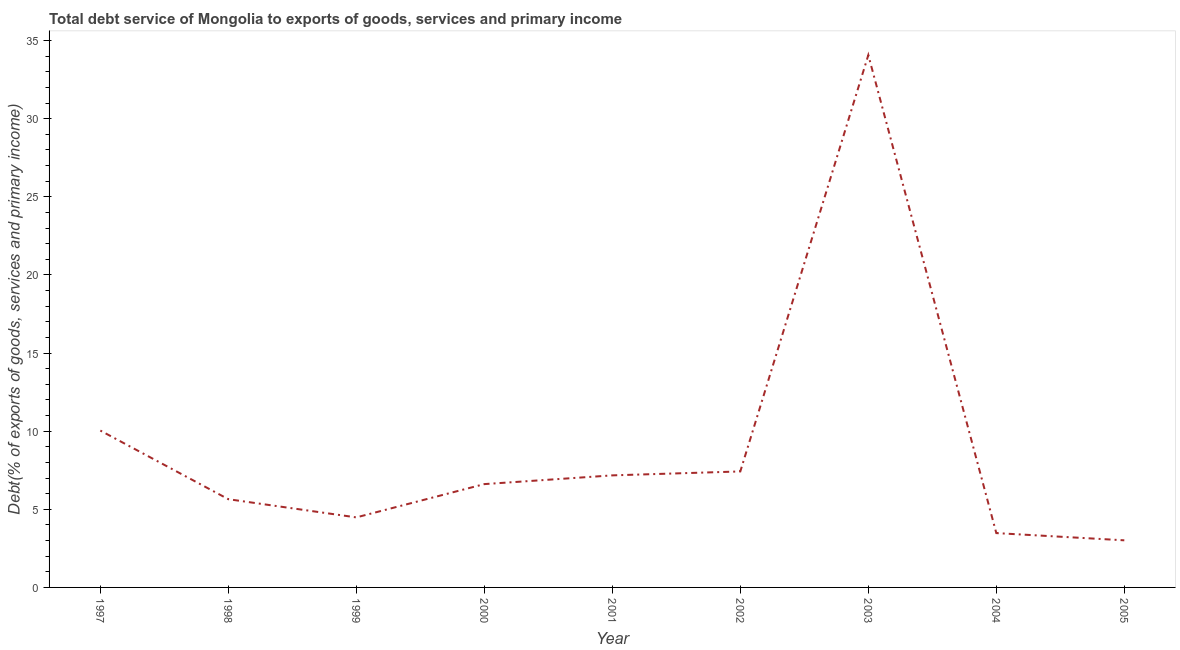What is the total debt service in 2005?
Provide a succinct answer. 3.02. Across all years, what is the maximum total debt service?
Provide a short and direct response. 34.07. Across all years, what is the minimum total debt service?
Provide a succinct answer. 3.02. In which year was the total debt service maximum?
Offer a very short reply. 2003. What is the sum of the total debt service?
Ensure brevity in your answer.  81.94. What is the difference between the total debt service in 1999 and 2004?
Make the answer very short. 1. What is the average total debt service per year?
Your response must be concise. 9.1. What is the median total debt service?
Offer a terse response. 6.61. In how many years, is the total debt service greater than 8 %?
Your answer should be very brief. 2. Do a majority of the years between 2001 and 2000 (inclusive) have total debt service greater than 34 %?
Your answer should be compact. No. What is the ratio of the total debt service in 1998 to that in 2000?
Provide a short and direct response. 0.85. Is the difference between the total debt service in 2000 and 2001 greater than the difference between any two years?
Offer a terse response. No. What is the difference between the highest and the second highest total debt service?
Make the answer very short. 24.03. What is the difference between the highest and the lowest total debt service?
Give a very brief answer. 31.06. How many lines are there?
Offer a terse response. 1. Are the values on the major ticks of Y-axis written in scientific E-notation?
Offer a terse response. No. Does the graph contain any zero values?
Give a very brief answer. No. What is the title of the graph?
Offer a terse response. Total debt service of Mongolia to exports of goods, services and primary income. What is the label or title of the X-axis?
Provide a succinct answer. Year. What is the label or title of the Y-axis?
Keep it short and to the point. Debt(% of exports of goods, services and primary income). What is the Debt(% of exports of goods, services and primary income) in 1997?
Make the answer very short. 10.04. What is the Debt(% of exports of goods, services and primary income) of 1998?
Provide a short and direct response. 5.65. What is the Debt(% of exports of goods, services and primary income) of 1999?
Provide a short and direct response. 4.48. What is the Debt(% of exports of goods, services and primary income) in 2000?
Provide a succinct answer. 6.61. What is the Debt(% of exports of goods, services and primary income) in 2001?
Ensure brevity in your answer.  7.17. What is the Debt(% of exports of goods, services and primary income) of 2002?
Provide a succinct answer. 7.42. What is the Debt(% of exports of goods, services and primary income) in 2003?
Your answer should be compact. 34.07. What is the Debt(% of exports of goods, services and primary income) in 2004?
Offer a very short reply. 3.48. What is the Debt(% of exports of goods, services and primary income) in 2005?
Provide a succinct answer. 3.02. What is the difference between the Debt(% of exports of goods, services and primary income) in 1997 and 1998?
Make the answer very short. 4.39. What is the difference between the Debt(% of exports of goods, services and primary income) in 1997 and 1999?
Give a very brief answer. 5.56. What is the difference between the Debt(% of exports of goods, services and primary income) in 1997 and 2000?
Offer a terse response. 3.43. What is the difference between the Debt(% of exports of goods, services and primary income) in 1997 and 2001?
Your answer should be very brief. 2.87. What is the difference between the Debt(% of exports of goods, services and primary income) in 1997 and 2002?
Your answer should be very brief. 2.62. What is the difference between the Debt(% of exports of goods, services and primary income) in 1997 and 2003?
Provide a short and direct response. -24.03. What is the difference between the Debt(% of exports of goods, services and primary income) in 1997 and 2004?
Offer a very short reply. 6.56. What is the difference between the Debt(% of exports of goods, services and primary income) in 1997 and 2005?
Provide a succinct answer. 7.02. What is the difference between the Debt(% of exports of goods, services and primary income) in 1998 and 1999?
Your response must be concise. 1.16. What is the difference between the Debt(% of exports of goods, services and primary income) in 1998 and 2000?
Provide a short and direct response. -0.97. What is the difference between the Debt(% of exports of goods, services and primary income) in 1998 and 2001?
Give a very brief answer. -1.53. What is the difference between the Debt(% of exports of goods, services and primary income) in 1998 and 2002?
Provide a short and direct response. -1.78. What is the difference between the Debt(% of exports of goods, services and primary income) in 1998 and 2003?
Offer a very short reply. -28.42. What is the difference between the Debt(% of exports of goods, services and primary income) in 1998 and 2004?
Offer a terse response. 2.17. What is the difference between the Debt(% of exports of goods, services and primary income) in 1998 and 2005?
Your answer should be very brief. 2.63. What is the difference between the Debt(% of exports of goods, services and primary income) in 1999 and 2000?
Keep it short and to the point. -2.13. What is the difference between the Debt(% of exports of goods, services and primary income) in 1999 and 2001?
Offer a terse response. -2.69. What is the difference between the Debt(% of exports of goods, services and primary income) in 1999 and 2002?
Ensure brevity in your answer.  -2.94. What is the difference between the Debt(% of exports of goods, services and primary income) in 1999 and 2003?
Provide a short and direct response. -29.59. What is the difference between the Debt(% of exports of goods, services and primary income) in 1999 and 2004?
Provide a short and direct response. 1. What is the difference between the Debt(% of exports of goods, services and primary income) in 1999 and 2005?
Ensure brevity in your answer.  1.47. What is the difference between the Debt(% of exports of goods, services and primary income) in 2000 and 2001?
Your answer should be compact. -0.56. What is the difference between the Debt(% of exports of goods, services and primary income) in 2000 and 2002?
Your response must be concise. -0.81. What is the difference between the Debt(% of exports of goods, services and primary income) in 2000 and 2003?
Your response must be concise. -27.46. What is the difference between the Debt(% of exports of goods, services and primary income) in 2000 and 2004?
Keep it short and to the point. 3.14. What is the difference between the Debt(% of exports of goods, services and primary income) in 2000 and 2005?
Ensure brevity in your answer.  3.6. What is the difference between the Debt(% of exports of goods, services and primary income) in 2001 and 2002?
Provide a short and direct response. -0.25. What is the difference between the Debt(% of exports of goods, services and primary income) in 2001 and 2003?
Offer a very short reply. -26.9. What is the difference between the Debt(% of exports of goods, services and primary income) in 2001 and 2004?
Your answer should be compact. 3.69. What is the difference between the Debt(% of exports of goods, services and primary income) in 2001 and 2005?
Provide a succinct answer. 4.16. What is the difference between the Debt(% of exports of goods, services and primary income) in 2002 and 2003?
Make the answer very short. -26.65. What is the difference between the Debt(% of exports of goods, services and primary income) in 2002 and 2004?
Give a very brief answer. 3.95. What is the difference between the Debt(% of exports of goods, services and primary income) in 2002 and 2005?
Ensure brevity in your answer.  4.41. What is the difference between the Debt(% of exports of goods, services and primary income) in 2003 and 2004?
Your response must be concise. 30.59. What is the difference between the Debt(% of exports of goods, services and primary income) in 2003 and 2005?
Provide a short and direct response. 31.06. What is the difference between the Debt(% of exports of goods, services and primary income) in 2004 and 2005?
Provide a short and direct response. 0.46. What is the ratio of the Debt(% of exports of goods, services and primary income) in 1997 to that in 1998?
Your answer should be very brief. 1.78. What is the ratio of the Debt(% of exports of goods, services and primary income) in 1997 to that in 1999?
Offer a terse response. 2.24. What is the ratio of the Debt(% of exports of goods, services and primary income) in 1997 to that in 2000?
Your response must be concise. 1.52. What is the ratio of the Debt(% of exports of goods, services and primary income) in 1997 to that in 2001?
Your answer should be compact. 1.4. What is the ratio of the Debt(% of exports of goods, services and primary income) in 1997 to that in 2002?
Your answer should be compact. 1.35. What is the ratio of the Debt(% of exports of goods, services and primary income) in 1997 to that in 2003?
Your answer should be compact. 0.29. What is the ratio of the Debt(% of exports of goods, services and primary income) in 1997 to that in 2004?
Offer a very short reply. 2.89. What is the ratio of the Debt(% of exports of goods, services and primary income) in 1997 to that in 2005?
Give a very brief answer. 3.33. What is the ratio of the Debt(% of exports of goods, services and primary income) in 1998 to that in 1999?
Provide a succinct answer. 1.26. What is the ratio of the Debt(% of exports of goods, services and primary income) in 1998 to that in 2000?
Your answer should be very brief. 0.85. What is the ratio of the Debt(% of exports of goods, services and primary income) in 1998 to that in 2001?
Make the answer very short. 0.79. What is the ratio of the Debt(% of exports of goods, services and primary income) in 1998 to that in 2002?
Your answer should be very brief. 0.76. What is the ratio of the Debt(% of exports of goods, services and primary income) in 1998 to that in 2003?
Give a very brief answer. 0.17. What is the ratio of the Debt(% of exports of goods, services and primary income) in 1998 to that in 2004?
Make the answer very short. 1.62. What is the ratio of the Debt(% of exports of goods, services and primary income) in 1998 to that in 2005?
Give a very brief answer. 1.87. What is the ratio of the Debt(% of exports of goods, services and primary income) in 1999 to that in 2000?
Make the answer very short. 0.68. What is the ratio of the Debt(% of exports of goods, services and primary income) in 1999 to that in 2002?
Provide a succinct answer. 0.6. What is the ratio of the Debt(% of exports of goods, services and primary income) in 1999 to that in 2003?
Your answer should be very brief. 0.13. What is the ratio of the Debt(% of exports of goods, services and primary income) in 1999 to that in 2004?
Your response must be concise. 1.29. What is the ratio of the Debt(% of exports of goods, services and primary income) in 1999 to that in 2005?
Offer a terse response. 1.49. What is the ratio of the Debt(% of exports of goods, services and primary income) in 2000 to that in 2001?
Make the answer very short. 0.92. What is the ratio of the Debt(% of exports of goods, services and primary income) in 2000 to that in 2002?
Give a very brief answer. 0.89. What is the ratio of the Debt(% of exports of goods, services and primary income) in 2000 to that in 2003?
Offer a terse response. 0.19. What is the ratio of the Debt(% of exports of goods, services and primary income) in 2000 to that in 2004?
Your response must be concise. 1.9. What is the ratio of the Debt(% of exports of goods, services and primary income) in 2000 to that in 2005?
Your answer should be very brief. 2.19. What is the ratio of the Debt(% of exports of goods, services and primary income) in 2001 to that in 2002?
Provide a succinct answer. 0.97. What is the ratio of the Debt(% of exports of goods, services and primary income) in 2001 to that in 2003?
Ensure brevity in your answer.  0.21. What is the ratio of the Debt(% of exports of goods, services and primary income) in 2001 to that in 2004?
Give a very brief answer. 2.06. What is the ratio of the Debt(% of exports of goods, services and primary income) in 2001 to that in 2005?
Your answer should be compact. 2.38. What is the ratio of the Debt(% of exports of goods, services and primary income) in 2002 to that in 2003?
Offer a very short reply. 0.22. What is the ratio of the Debt(% of exports of goods, services and primary income) in 2002 to that in 2004?
Your answer should be compact. 2.13. What is the ratio of the Debt(% of exports of goods, services and primary income) in 2002 to that in 2005?
Provide a succinct answer. 2.46. What is the ratio of the Debt(% of exports of goods, services and primary income) in 2003 to that in 2004?
Ensure brevity in your answer.  9.8. What is the ratio of the Debt(% of exports of goods, services and primary income) in 2003 to that in 2005?
Provide a succinct answer. 11.3. What is the ratio of the Debt(% of exports of goods, services and primary income) in 2004 to that in 2005?
Provide a succinct answer. 1.15. 